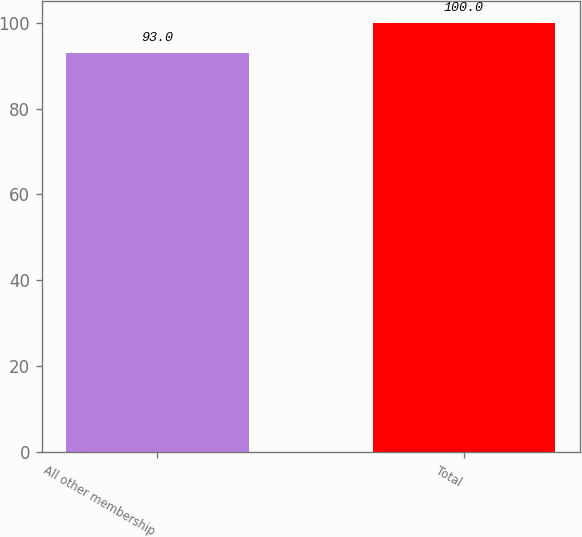<chart> <loc_0><loc_0><loc_500><loc_500><bar_chart><fcel>All other membership<fcel>Total<nl><fcel>93<fcel>100<nl></chart> 